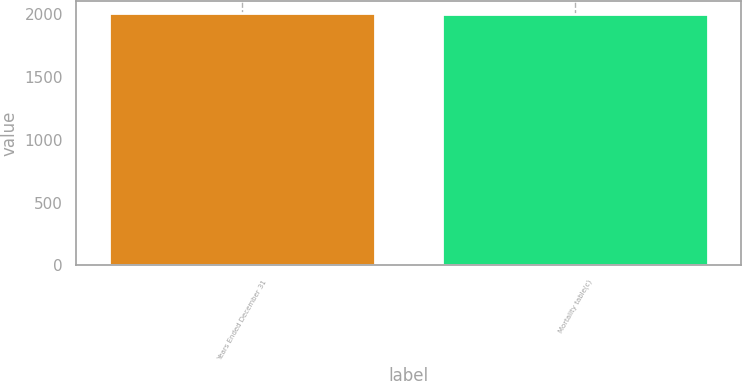Convert chart to OTSL. <chart><loc_0><loc_0><loc_500><loc_500><bar_chart><fcel>Years Ended December 31<fcel>Mortality table(c)<nl><fcel>2006<fcel>2000<nl></chart> 